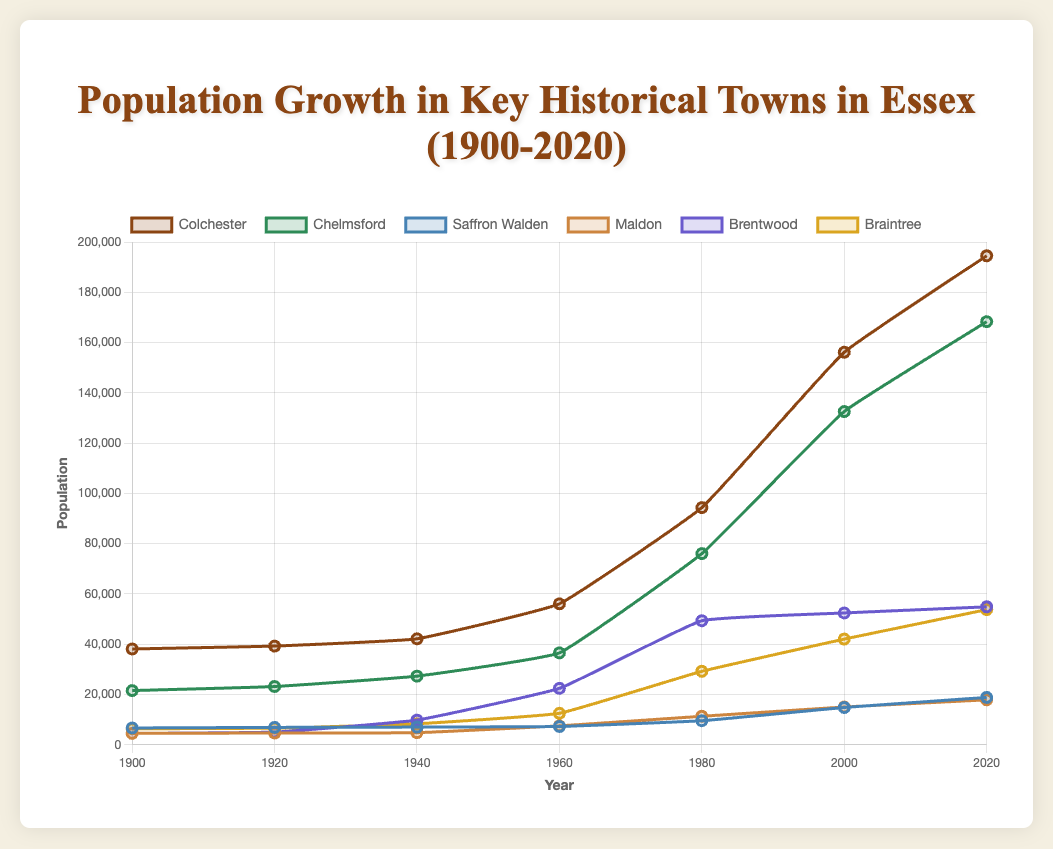What is the population difference between Colchester and Chelmsford in 2020? The population of Colchester in 2020 is 194,519, and the population of Chelmsford in 2020 is 168,310. The difference is calculated as 194,519 - 168,310.
Answer: 26,209 Which town had the largest population growth from 2000 to 2020? By examining the differences in population for each town between 2000 and 2020: Colchester: 194,519 - 156,150 = 38,369; Chelmsford: 168,310 - 132,563 = 35,747; Saffron Walden: 18,852 - 14,832 = 4,020; Maldon: 17,891 - 15,023 = 2,868; Brentwood: 54,885 - 52,440 = 2,445; Braintree: 53,765 - 42,045 = 11,720. The largest growth is in Colchester.
Answer: Colchester In which decade did Braintree experience the highest relative population growth rate? Relative population growth rate is determined by the percentage change over each decade compared to the starting population for each period. Calculate for each decade: 1900-1920: (6,620 - 6,370) / 6,370 ≈ 0.039 or 3.9%; 1920-1940: (8,352 - 6,620) / 6,620 ≈ 0.261 or 26.1%; 1940-1960: (12,540 - 8,352) / 8,352 ≈ 0.502 or 50.2%; 1960-1980: (29,230 - 12,540) / 12,540 ≈ 1.33 or 133%; 1980-2000: (42,045 - 29,230) / 29,230 ≈ 0.438 or 43.8%; 2000-2020: (53,765 - 42,045) / 42,045 ≈ 0.279 or 27.9%. The highest rate is in the decade 1960-1980.
Answer: 1960-1980 What was the population of Saffron Walden in 1960, and how does it compare to its population in 1920? The population of Saffron Walden in 1960 was 7,290, and in 1920 it was 6,920. Comparing these: 7,290 - 6,920 = 370.
Answer: Population increased by 370 Among Colchester, Chelmsford, and Maldon, which town had the smallest population in 2000? According to the data, the populations in 2000 were Colchester: 156,150; Chelmsford: 132,563; Maldon: 15,023. Maldon had the smallest population.
Answer: Maldon By how much did the population of Brentwood increase from 1940 to 1960? The population of Brentwood was 9,821 in 1940 and increased to 22,450 in 1960. Therefore, the increase is calculated as 22,450 - 9,821.
Answer: 12,629 What is the average population of Chelmsford in the decades 1900, 1920, and 1940? The populations of Chelmsford in these decades are 21,565 (1900), 23,174 (1920), and 27,310 (1940). The average is calculated as (21,565 + 23,174 + 27,310) / 3.
Answer: 24,016.33 